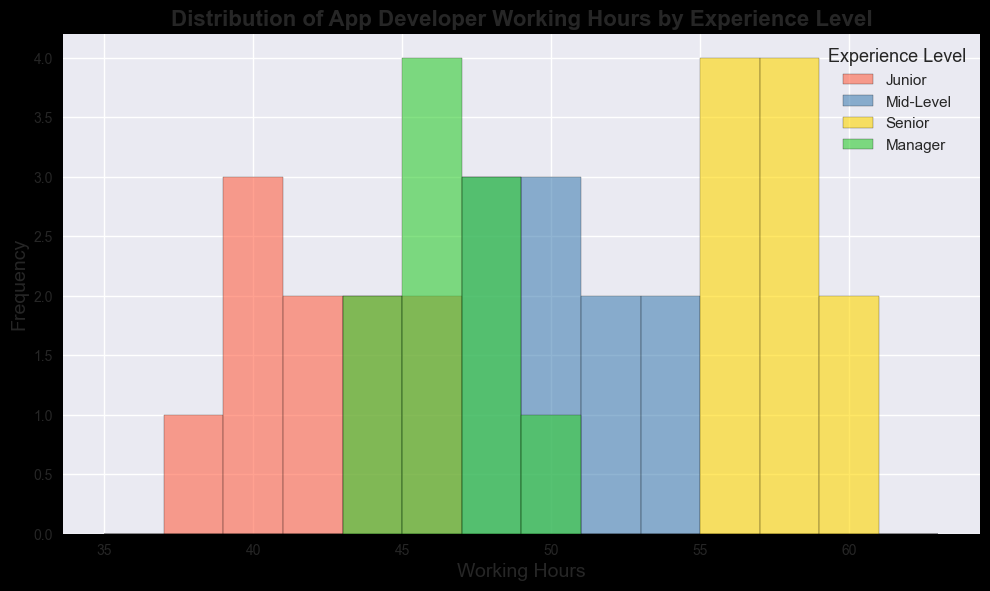What is the most frequent working hours range for Mid-Level app developers? To determine the most frequent working hours range for Mid-Level app developers, look at the bars in the histogram for Mid-Level (blue bars) which have the highest height.
Answer: 48-50 hours Which experience level has the widest range of working hours? To find the experience level with the widest range of working hours, compare the spread of the bars for each experience group. "Senior" experience level (green bars) ranges from 55 to 60 hours.
Answer: Senior Are Junior or Senior developers working more hours on average? To determine the average working hours, compare the central tendencies of the histograms for Junior (red) and Senior (green). Senior developers generally have working hours clustered between 55 to 60, higher than the 38 to 46 for Juniors.
Answer: Senior Which experience level shows the least variability in working hours? Variability can be inferred by looking at the width of the histogram distribution. The "Manager" level (yellow bars) shows less spread compared to the others, indicating less variability.
Answer: Manager Does any experience level have overlapping working hours with another level? Check if there are any ranges in which two different colors overlap or are adjacent to each other. For example, "Junior" (red) and "Mid-Level" (blue) both have working hours around 45-46.
Answer: Yes What is the second most common working hours range for Managers? Look at the yellow bars representing Managers. The tallest bar represents the most common range, and the second tallest bar would be the second most common range.
Answer: 47-48 hours Which experience level has the lowest number of working hours in the distribution? To find the lowest number of working hours, look for the starting point of the first bar for each color. The red bar corresponding to Juniors starts at 38 hours.
Answer: Junior How do the working hours for managers compare with those for seniors in terms of general range? Compare the range of yellow bars (Managers) with green bars (Seniors) in the histogram. Managers fall between 43-49 while Seniors fall between 55-60.
Answer: Managers work fewer hours What's the average working hours range for Junior developers? By observing all the red bars representing Junior developers and estimating the central tendency, most frequent values fall between 40-43 hours.
Answer: 40-43 hours 